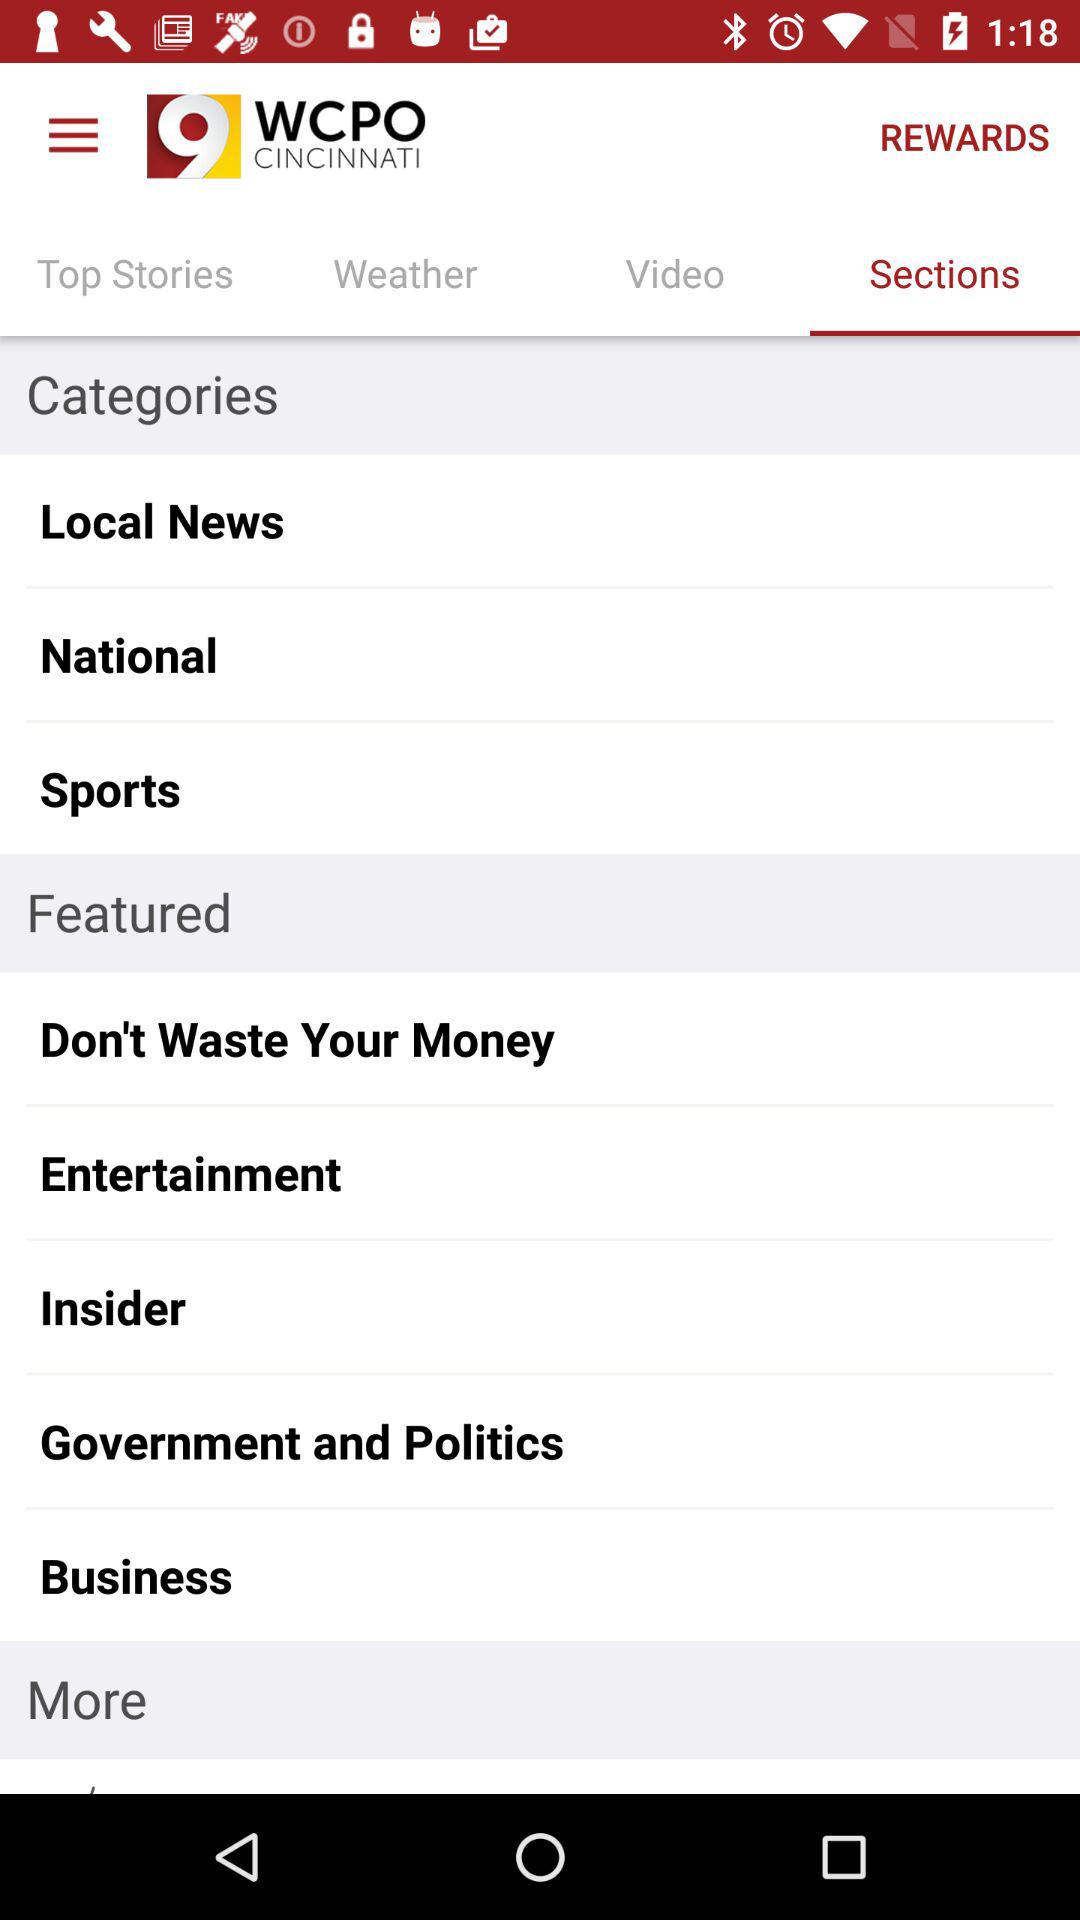Which tab is selected? The selected tab is "Sections". 